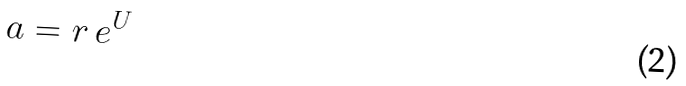<formula> <loc_0><loc_0><loc_500><loc_500>a = r \, e ^ { U }</formula> 